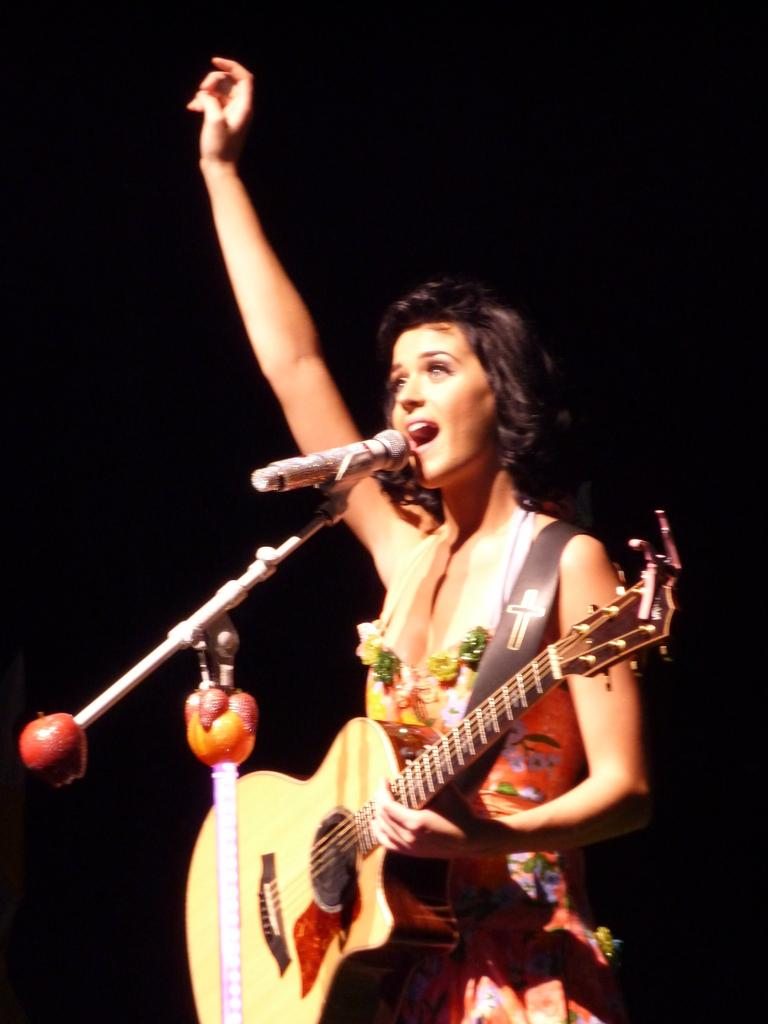Who is the main subject in the image? There is a lady in the image. What is the lady doing in the image? The lady is standing and singing a song. What object is the lady holding in her hand? The lady is holding a guitar in her hand. What device is placed before the lady? There is a microphone placed before her. What type of pig can be seen in the image? There is no pig present in the image. What is the view from the floor in the image? The image does not show a floor or a view from it, as it focuses on the lady and her performance. 